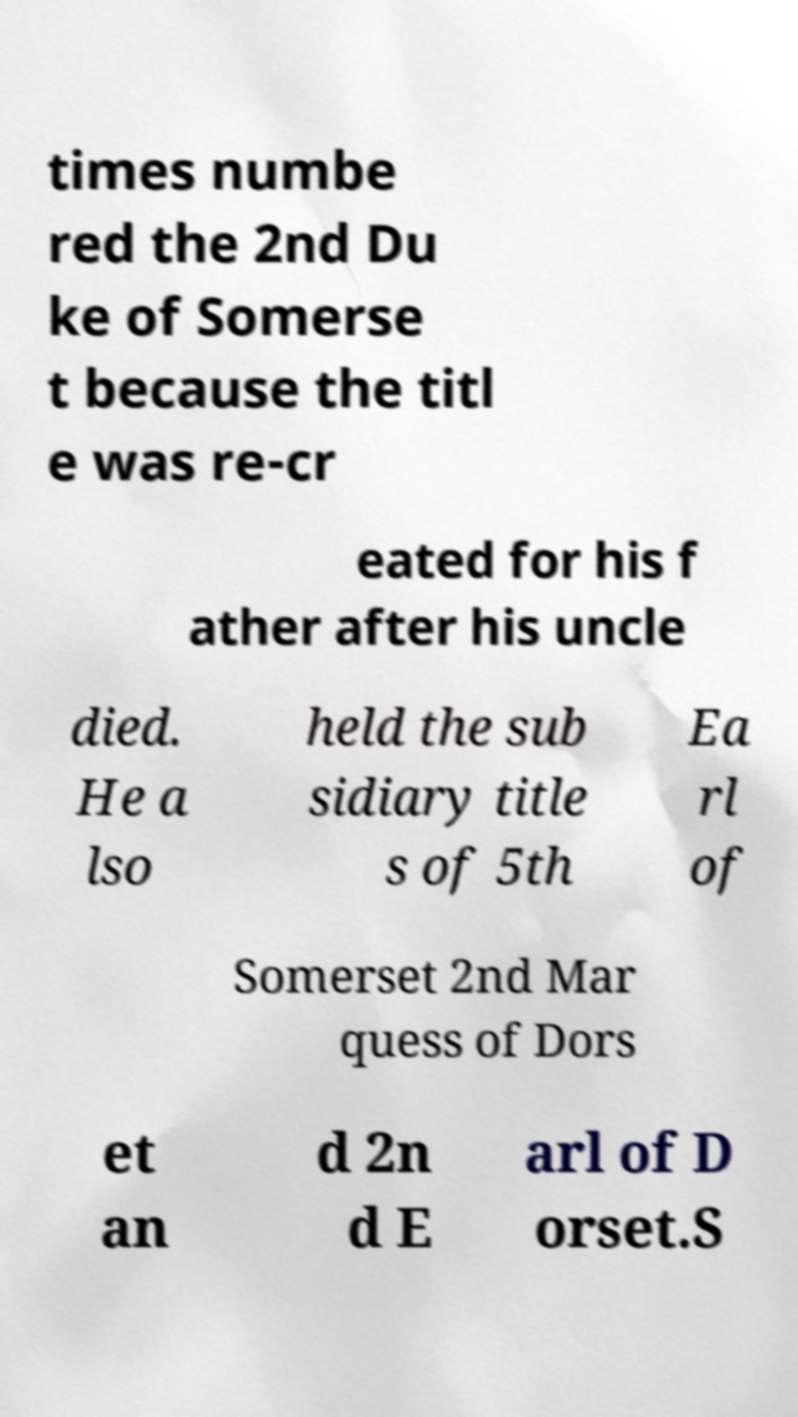Please identify and transcribe the text found in this image. times numbe red the 2nd Du ke of Somerse t because the titl e was re-cr eated for his f ather after his uncle died. He a lso held the sub sidiary title s of 5th Ea rl of Somerset 2nd Mar quess of Dors et an d 2n d E arl of D orset.S 